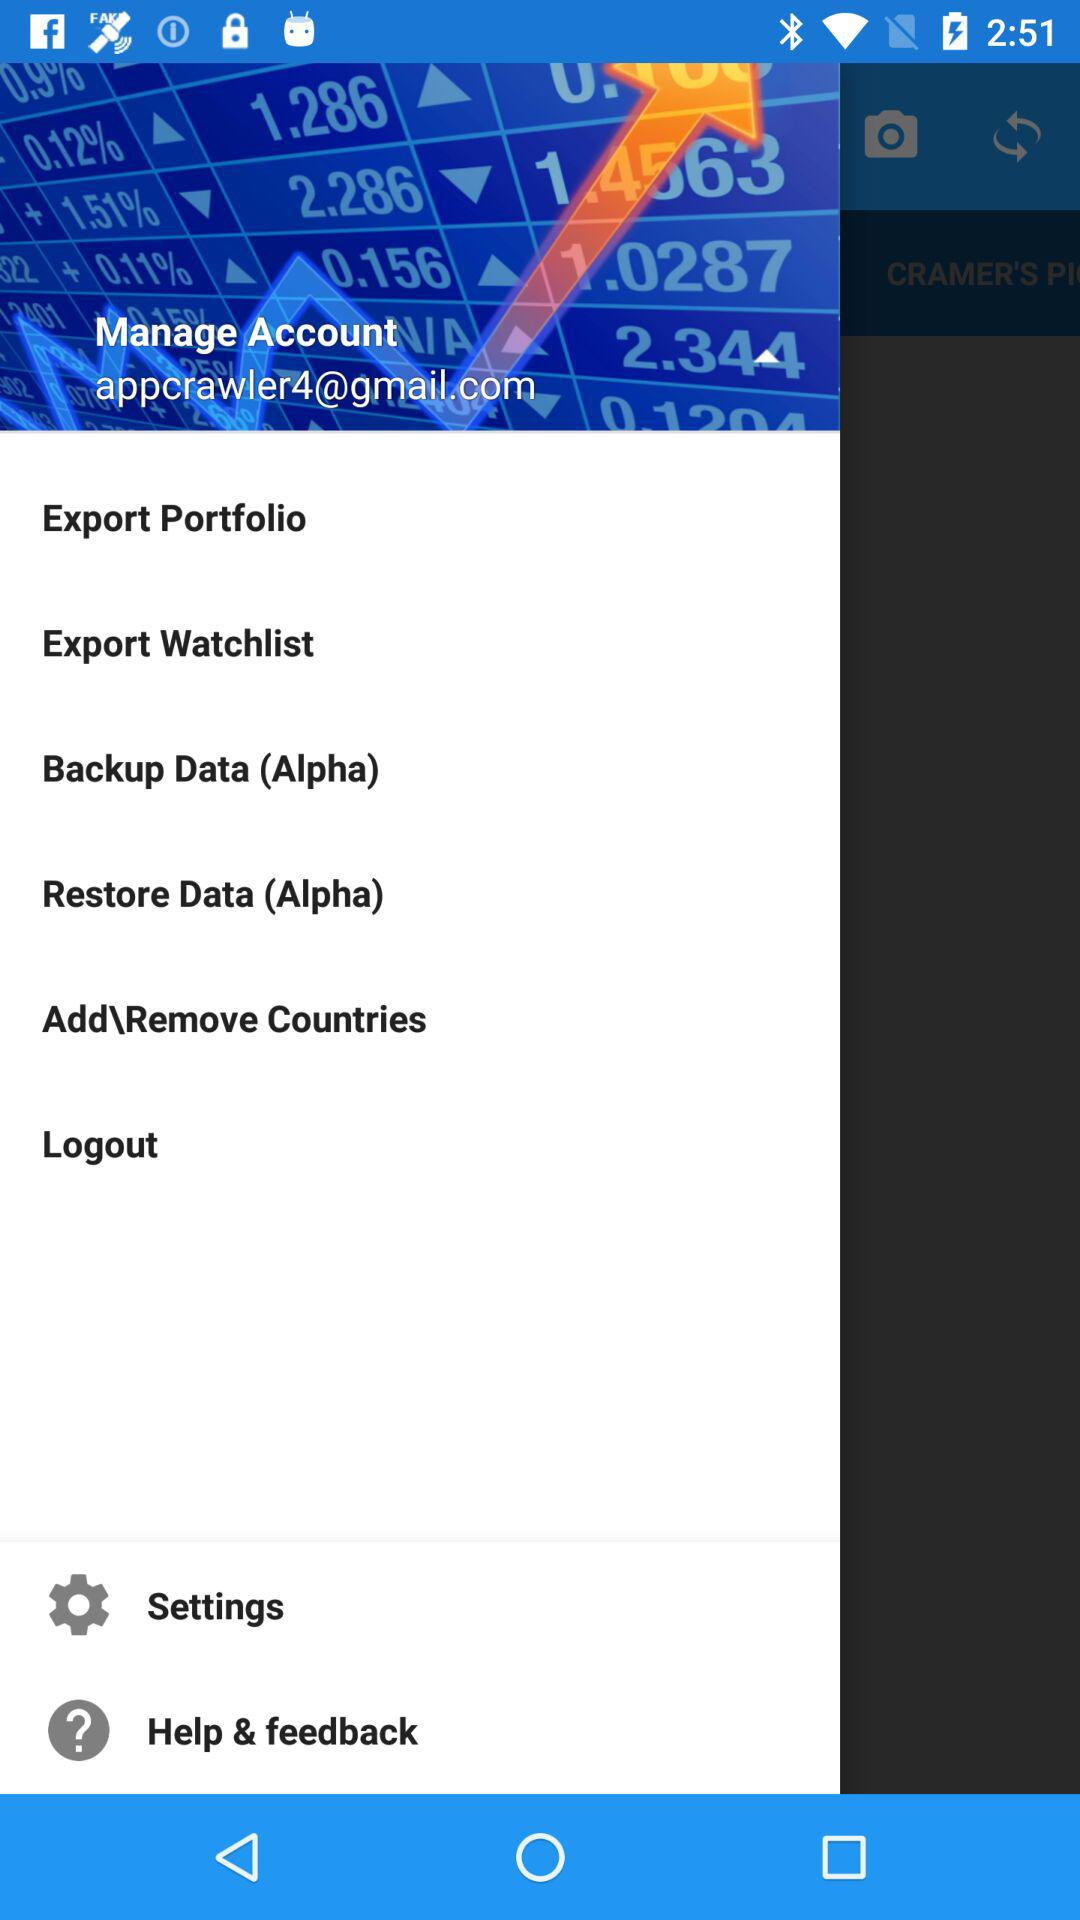What is the email address? The email address is appcrawler4@gmail.com. 